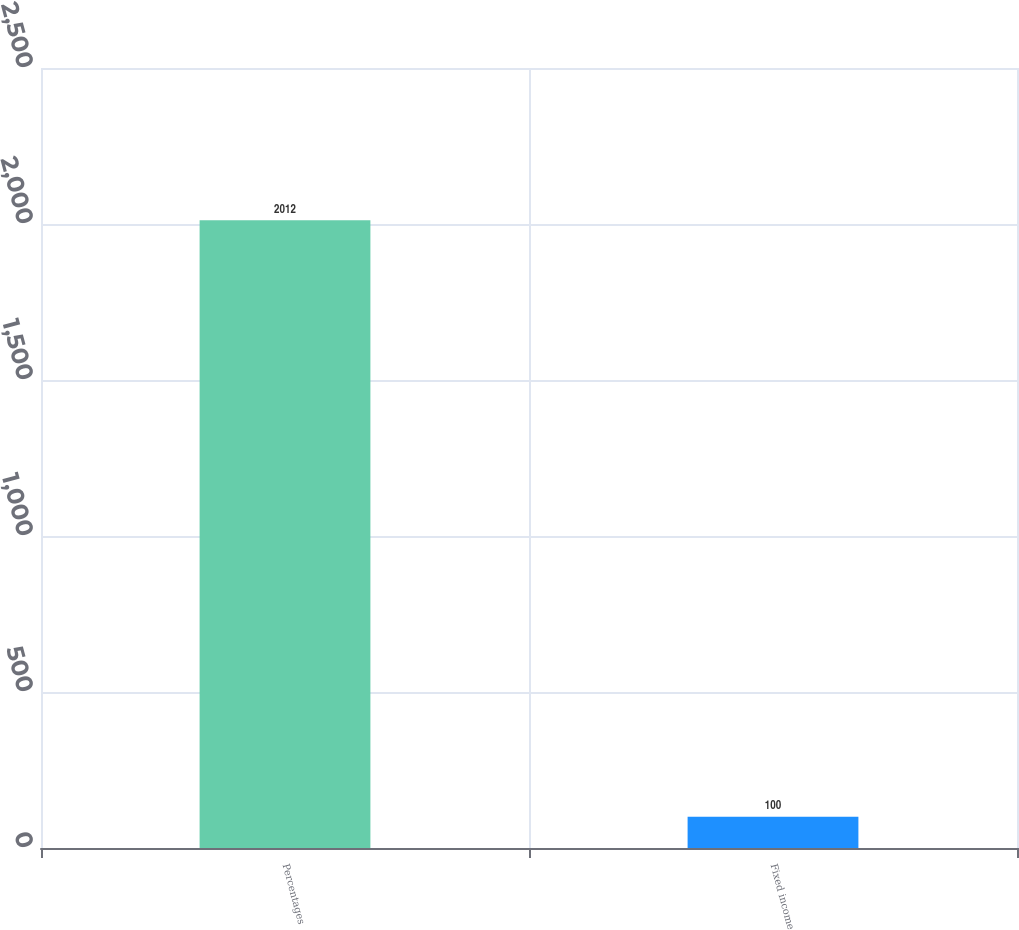Convert chart. <chart><loc_0><loc_0><loc_500><loc_500><bar_chart><fcel>Percentages<fcel>Fixed income<nl><fcel>2012<fcel>100<nl></chart> 